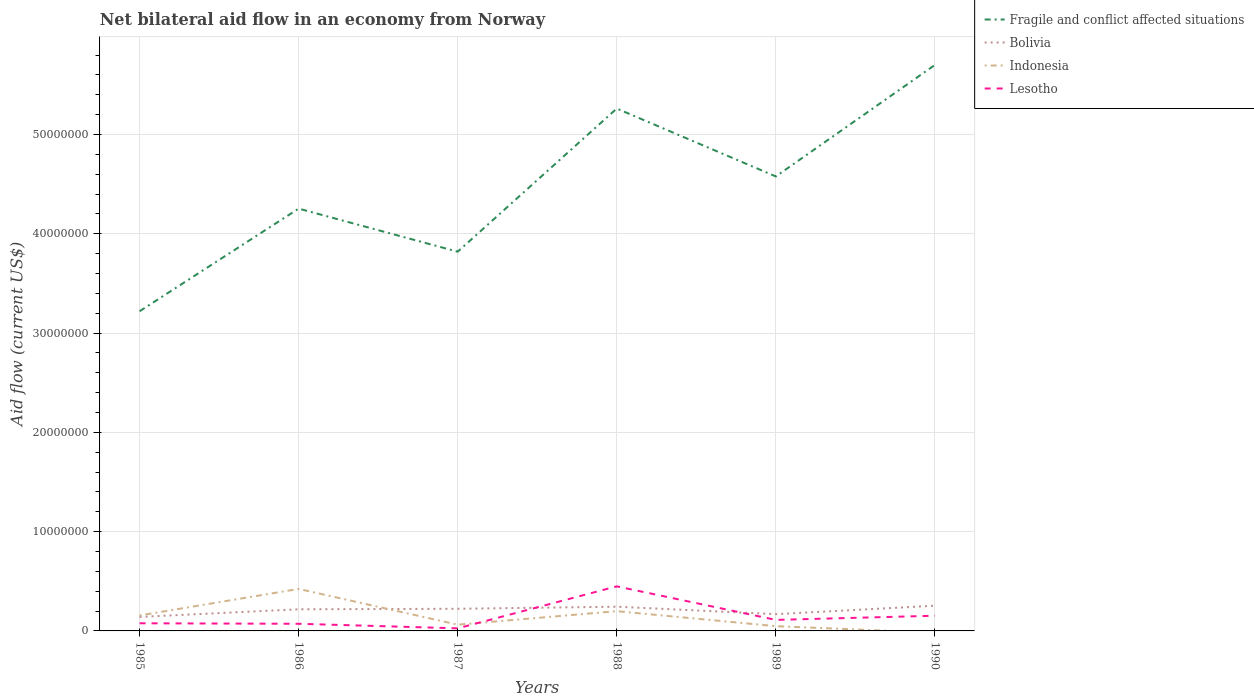Across all years, what is the maximum net bilateral aid flow in Bolivia?
Your answer should be compact. 1.41e+06. What is the total net bilateral aid flow in Lesotho in the graph?
Keep it short and to the point. 5.00e+04. What is the difference between the highest and the second highest net bilateral aid flow in Fragile and conflict affected situations?
Offer a very short reply. 2.48e+07. Is the net bilateral aid flow in Bolivia strictly greater than the net bilateral aid flow in Lesotho over the years?
Provide a succinct answer. No. How many years are there in the graph?
Your answer should be very brief. 6. Are the values on the major ticks of Y-axis written in scientific E-notation?
Provide a short and direct response. No. Where does the legend appear in the graph?
Make the answer very short. Top right. How many legend labels are there?
Offer a terse response. 4. What is the title of the graph?
Your answer should be compact. Net bilateral aid flow in an economy from Norway. What is the label or title of the Y-axis?
Your response must be concise. Aid flow (current US$). What is the Aid flow (current US$) in Fragile and conflict affected situations in 1985?
Provide a succinct answer. 3.22e+07. What is the Aid flow (current US$) of Bolivia in 1985?
Keep it short and to the point. 1.41e+06. What is the Aid flow (current US$) in Indonesia in 1985?
Offer a very short reply. 1.56e+06. What is the Aid flow (current US$) of Lesotho in 1985?
Ensure brevity in your answer.  7.70e+05. What is the Aid flow (current US$) in Fragile and conflict affected situations in 1986?
Your answer should be compact. 4.25e+07. What is the Aid flow (current US$) of Bolivia in 1986?
Provide a succinct answer. 2.18e+06. What is the Aid flow (current US$) in Indonesia in 1986?
Make the answer very short. 4.23e+06. What is the Aid flow (current US$) in Lesotho in 1986?
Provide a short and direct response. 7.20e+05. What is the Aid flow (current US$) of Fragile and conflict affected situations in 1987?
Offer a very short reply. 3.82e+07. What is the Aid flow (current US$) of Bolivia in 1987?
Offer a terse response. 2.23e+06. What is the Aid flow (current US$) of Indonesia in 1987?
Offer a terse response. 6.30e+05. What is the Aid flow (current US$) in Fragile and conflict affected situations in 1988?
Offer a very short reply. 5.26e+07. What is the Aid flow (current US$) in Bolivia in 1988?
Ensure brevity in your answer.  2.44e+06. What is the Aid flow (current US$) in Indonesia in 1988?
Make the answer very short. 1.99e+06. What is the Aid flow (current US$) in Lesotho in 1988?
Your answer should be very brief. 4.49e+06. What is the Aid flow (current US$) in Fragile and conflict affected situations in 1989?
Give a very brief answer. 4.58e+07. What is the Aid flow (current US$) of Bolivia in 1989?
Offer a terse response. 1.69e+06. What is the Aid flow (current US$) of Lesotho in 1989?
Offer a very short reply. 1.11e+06. What is the Aid flow (current US$) in Fragile and conflict affected situations in 1990?
Keep it short and to the point. 5.70e+07. What is the Aid flow (current US$) in Bolivia in 1990?
Your answer should be compact. 2.54e+06. What is the Aid flow (current US$) in Indonesia in 1990?
Offer a very short reply. 0. What is the Aid flow (current US$) of Lesotho in 1990?
Keep it short and to the point. 1.53e+06. Across all years, what is the maximum Aid flow (current US$) in Fragile and conflict affected situations?
Your response must be concise. 5.70e+07. Across all years, what is the maximum Aid flow (current US$) in Bolivia?
Provide a short and direct response. 2.54e+06. Across all years, what is the maximum Aid flow (current US$) in Indonesia?
Ensure brevity in your answer.  4.23e+06. Across all years, what is the maximum Aid flow (current US$) of Lesotho?
Ensure brevity in your answer.  4.49e+06. Across all years, what is the minimum Aid flow (current US$) in Fragile and conflict affected situations?
Offer a terse response. 3.22e+07. Across all years, what is the minimum Aid flow (current US$) of Bolivia?
Your answer should be very brief. 1.41e+06. Across all years, what is the minimum Aid flow (current US$) in Lesotho?
Give a very brief answer. 2.60e+05. What is the total Aid flow (current US$) in Fragile and conflict affected situations in the graph?
Make the answer very short. 2.68e+08. What is the total Aid flow (current US$) of Bolivia in the graph?
Ensure brevity in your answer.  1.25e+07. What is the total Aid flow (current US$) of Indonesia in the graph?
Offer a terse response. 8.89e+06. What is the total Aid flow (current US$) in Lesotho in the graph?
Your response must be concise. 8.88e+06. What is the difference between the Aid flow (current US$) in Fragile and conflict affected situations in 1985 and that in 1986?
Your answer should be very brief. -1.03e+07. What is the difference between the Aid flow (current US$) of Bolivia in 1985 and that in 1986?
Keep it short and to the point. -7.70e+05. What is the difference between the Aid flow (current US$) in Indonesia in 1985 and that in 1986?
Offer a very short reply. -2.67e+06. What is the difference between the Aid flow (current US$) in Fragile and conflict affected situations in 1985 and that in 1987?
Your answer should be very brief. -6.00e+06. What is the difference between the Aid flow (current US$) of Bolivia in 1985 and that in 1987?
Provide a succinct answer. -8.20e+05. What is the difference between the Aid flow (current US$) of Indonesia in 1985 and that in 1987?
Ensure brevity in your answer.  9.30e+05. What is the difference between the Aid flow (current US$) of Lesotho in 1985 and that in 1987?
Your answer should be compact. 5.10e+05. What is the difference between the Aid flow (current US$) in Fragile and conflict affected situations in 1985 and that in 1988?
Offer a terse response. -2.04e+07. What is the difference between the Aid flow (current US$) of Bolivia in 1985 and that in 1988?
Offer a terse response. -1.03e+06. What is the difference between the Aid flow (current US$) of Indonesia in 1985 and that in 1988?
Keep it short and to the point. -4.30e+05. What is the difference between the Aid flow (current US$) of Lesotho in 1985 and that in 1988?
Your answer should be very brief. -3.72e+06. What is the difference between the Aid flow (current US$) in Fragile and conflict affected situations in 1985 and that in 1989?
Provide a succinct answer. -1.36e+07. What is the difference between the Aid flow (current US$) of Bolivia in 1985 and that in 1989?
Give a very brief answer. -2.80e+05. What is the difference between the Aid flow (current US$) of Indonesia in 1985 and that in 1989?
Your response must be concise. 1.08e+06. What is the difference between the Aid flow (current US$) in Fragile and conflict affected situations in 1985 and that in 1990?
Provide a succinct answer. -2.48e+07. What is the difference between the Aid flow (current US$) of Bolivia in 1985 and that in 1990?
Keep it short and to the point. -1.13e+06. What is the difference between the Aid flow (current US$) in Lesotho in 1985 and that in 1990?
Your answer should be compact. -7.60e+05. What is the difference between the Aid flow (current US$) in Fragile and conflict affected situations in 1986 and that in 1987?
Your response must be concise. 4.34e+06. What is the difference between the Aid flow (current US$) of Bolivia in 1986 and that in 1987?
Your response must be concise. -5.00e+04. What is the difference between the Aid flow (current US$) of Indonesia in 1986 and that in 1987?
Offer a terse response. 3.60e+06. What is the difference between the Aid flow (current US$) in Lesotho in 1986 and that in 1987?
Your response must be concise. 4.60e+05. What is the difference between the Aid flow (current US$) of Fragile and conflict affected situations in 1986 and that in 1988?
Provide a succinct answer. -1.01e+07. What is the difference between the Aid flow (current US$) of Indonesia in 1986 and that in 1988?
Your answer should be compact. 2.24e+06. What is the difference between the Aid flow (current US$) in Lesotho in 1986 and that in 1988?
Your answer should be very brief. -3.77e+06. What is the difference between the Aid flow (current US$) in Fragile and conflict affected situations in 1986 and that in 1989?
Provide a succinct answer. -3.24e+06. What is the difference between the Aid flow (current US$) of Indonesia in 1986 and that in 1989?
Offer a very short reply. 3.75e+06. What is the difference between the Aid flow (current US$) in Lesotho in 1986 and that in 1989?
Provide a short and direct response. -3.90e+05. What is the difference between the Aid flow (current US$) in Fragile and conflict affected situations in 1986 and that in 1990?
Your answer should be compact. -1.45e+07. What is the difference between the Aid flow (current US$) in Bolivia in 1986 and that in 1990?
Your answer should be very brief. -3.60e+05. What is the difference between the Aid flow (current US$) of Lesotho in 1986 and that in 1990?
Offer a very short reply. -8.10e+05. What is the difference between the Aid flow (current US$) in Fragile and conflict affected situations in 1987 and that in 1988?
Make the answer very short. -1.44e+07. What is the difference between the Aid flow (current US$) of Indonesia in 1987 and that in 1988?
Offer a terse response. -1.36e+06. What is the difference between the Aid flow (current US$) of Lesotho in 1987 and that in 1988?
Give a very brief answer. -4.23e+06. What is the difference between the Aid flow (current US$) of Fragile and conflict affected situations in 1987 and that in 1989?
Your answer should be very brief. -7.58e+06. What is the difference between the Aid flow (current US$) of Bolivia in 1987 and that in 1989?
Ensure brevity in your answer.  5.40e+05. What is the difference between the Aid flow (current US$) in Indonesia in 1987 and that in 1989?
Your answer should be compact. 1.50e+05. What is the difference between the Aid flow (current US$) in Lesotho in 1987 and that in 1989?
Make the answer very short. -8.50e+05. What is the difference between the Aid flow (current US$) in Fragile and conflict affected situations in 1987 and that in 1990?
Offer a terse response. -1.88e+07. What is the difference between the Aid flow (current US$) in Bolivia in 1987 and that in 1990?
Provide a succinct answer. -3.10e+05. What is the difference between the Aid flow (current US$) in Lesotho in 1987 and that in 1990?
Your answer should be very brief. -1.27e+06. What is the difference between the Aid flow (current US$) of Fragile and conflict affected situations in 1988 and that in 1989?
Give a very brief answer. 6.84e+06. What is the difference between the Aid flow (current US$) in Bolivia in 1988 and that in 1989?
Give a very brief answer. 7.50e+05. What is the difference between the Aid flow (current US$) in Indonesia in 1988 and that in 1989?
Your response must be concise. 1.51e+06. What is the difference between the Aid flow (current US$) of Lesotho in 1988 and that in 1989?
Ensure brevity in your answer.  3.38e+06. What is the difference between the Aid flow (current US$) in Fragile and conflict affected situations in 1988 and that in 1990?
Offer a terse response. -4.39e+06. What is the difference between the Aid flow (current US$) in Bolivia in 1988 and that in 1990?
Keep it short and to the point. -1.00e+05. What is the difference between the Aid flow (current US$) in Lesotho in 1988 and that in 1990?
Your answer should be compact. 2.96e+06. What is the difference between the Aid flow (current US$) of Fragile and conflict affected situations in 1989 and that in 1990?
Provide a succinct answer. -1.12e+07. What is the difference between the Aid flow (current US$) of Bolivia in 1989 and that in 1990?
Make the answer very short. -8.50e+05. What is the difference between the Aid flow (current US$) of Lesotho in 1989 and that in 1990?
Provide a succinct answer. -4.20e+05. What is the difference between the Aid flow (current US$) in Fragile and conflict affected situations in 1985 and the Aid flow (current US$) in Bolivia in 1986?
Provide a short and direct response. 3.00e+07. What is the difference between the Aid flow (current US$) in Fragile and conflict affected situations in 1985 and the Aid flow (current US$) in Indonesia in 1986?
Provide a short and direct response. 2.80e+07. What is the difference between the Aid flow (current US$) in Fragile and conflict affected situations in 1985 and the Aid flow (current US$) in Lesotho in 1986?
Give a very brief answer. 3.15e+07. What is the difference between the Aid flow (current US$) of Bolivia in 1985 and the Aid flow (current US$) of Indonesia in 1986?
Keep it short and to the point. -2.82e+06. What is the difference between the Aid flow (current US$) in Bolivia in 1985 and the Aid flow (current US$) in Lesotho in 1986?
Your answer should be compact. 6.90e+05. What is the difference between the Aid flow (current US$) of Indonesia in 1985 and the Aid flow (current US$) of Lesotho in 1986?
Offer a very short reply. 8.40e+05. What is the difference between the Aid flow (current US$) in Fragile and conflict affected situations in 1985 and the Aid flow (current US$) in Bolivia in 1987?
Your answer should be compact. 3.00e+07. What is the difference between the Aid flow (current US$) of Fragile and conflict affected situations in 1985 and the Aid flow (current US$) of Indonesia in 1987?
Keep it short and to the point. 3.16e+07. What is the difference between the Aid flow (current US$) of Fragile and conflict affected situations in 1985 and the Aid flow (current US$) of Lesotho in 1987?
Your response must be concise. 3.19e+07. What is the difference between the Aid flow (current US$) of Bolivia in 1985 and the Aid flow (current US$) of Indonesia in 1987?
Ensure brevity in your answer.  7.80e+05. What is the difference between the Aid flow (current US$) of Bolivia in 1985 and the Aid flow (current US$) of Lesotho in 1987?
Make the answer very short. 1.15e+06. What is the difference between the Aid flow (current US$) of Indonesia in 1985 and the Aid flow (current US$) of Lesotho in 1987?
Your answer should be compact. 1.30e+06. What is the difference between the Aid flow (current US$) of Fragile and conflict affected situations in 1985 and the Aid flow (current US$) of Bolivia in 1988?
Ensure brevity in your answer.  2.98e+07. What is the difference between the Aid flow (current US$) in Fragile and conflict affected situations in 1985 and the Aid flow (current US$) in Indonesia in 1988?
Offer a very short reply. 3.02e+07. What is the difference between the Aid flow (current US$) of Fragile and conflict affected situations in 1985 and the Aid flow (current US$) of Lesotho in 1988?
Provide a short and direct response. 2.77e+07. What is the difference between the Aid flow (current US$) in Bolivia in 1985 and the Aid flow (current US$) in Indonesia in 1988?
Give a very brief answer. -5.80e+05. What is the difference between the Aid flow (current US$) in Bolivia in 1985 and the Aid flow (current US$) in Lesotho in 1988?
Ensure brevity in your answer.  -3.08e+06. What is the difference between the Aid flow (current US$) of Indonesia in 1985 and the Aid flow (current US$) of Lesotho in 1988?
Provide a succinct answer. -2.93e+06. What is the difference between the Aid flow (current US$) in Fragile and conflict affected situations in 1985 and the Aid flow (current US$) in Bolivia in 1989?
Offer a very short reply. 3.05e+07. What is the difference between the Aid flow (current US$) in Fragile and conflict affected situations in 1985 and the Aid flow (current US$) in Indonesia in 1989?
Keep it short and to the point. 3.17e+07. What is the difference between the Aid flow (current US$) in Fragile and conflict affected situations in 1985 and the Aid flow (current US$) in Lesotho in 1989?
Provide a succinct answer. 3.11e+07. What is the difference between the Aid flow (current US$) of Bolivia in 1985 and the Aid flow (current US$) of Indonesia in 1989?
Your answer should be compact. 9.30e+05. What is the difference between the Aid flow (current US$) of Indonesia in 1985 and the Aid flow (current US$) of Lesotho in 1989?
Make the answer very short. 4.50e+05. What is the difference between the Aid flow (current US$) of Fragile and conflict affected situations in 1985 and the Aid flow (current US$) of Bolivia in 1990?
Your answer should be very brief. 2.97e+07. What is the difference between the Aid flow (current US$) of Fragile and conflict affected situations in 1985 and the Aid flow (current US$) of Lesotho in 1990?
Your answer should be very brief. 3.07e+07. What is the difference between the Aid flow (current US$) of Fragile and conflict affected situations in 1986 and the Aid flow (current US$) of Bolivia in 1987?
Your answer should be compact. 4.03e+07. What is the difference between the Aid flow (current US$) of Fragile and conflict affected situations in 1986 and the Aid flow (current US$) of Indonesia in 1987?
Offer a very short reply. 4.19e+07. What is the difference between the Aid flow (current US$) of Fragile and conflict affected situations in 1986 and the Aid flow (current US$) of Lesotho in 1987?
Make the answer very short. 4.23e+07. What is the difference between the Aid flow (current US$) in Bolivia in 1986 and the Aid flow (current US$) in Indonesia in 1987?
Your response must be concise. 1.55e+06. What is the difference between the Aid flow (current US$) of Bolivia in 1986 and the Aid flow (current US$) of Lesotho in 1987?
Your answer should be compact. 1.92e+06. What is the difference between the Aid flow (current US$) in Indonesia in 1986 and the Aid flow (current US$) in Lesotho in 1987?
Make the answer very short. 3.97e+06. What is the difference between the Aid flow (current US$) in Fragile and conflict affected situations in 1986 and the Aid flow (current US$) in Bolivia in 1988?
Make the answer very short. 4.01e+07. What is the difference between the Aid flow (current US$) in Fragile and conflict affected situations in 1986 and the Aid flow (current US$) in Indonesia in 1988?
Keep it short and to the point. 4.06e+07. What is the difference between the Aid flow (current US$) of Fragile and conflict affected situations in 1986 and the Aid flow (current US$) of Lesotho in 1988?
Ensure brevity in your answer.  3.80e+07. What is the difference between the Aid flow (current US$) of Bolivia in 1986 and the Aid flow (current US$) of Indonesia in 1988?
Give a very brief answer. 1.90e+05. What is the difference between the Aid flow (current US$) of Bolivia in 1986 and the Aid flow (current US$) of Lesotho in 1988?
Provide a succinct answer. -2.31e+06. What is the difference between the Aid flow (current US$) of Indonesia in 1986 and the Aid flow (current US$) of Lesotho in 1988?
Offer a terse response. -2.60e+05. What is the difference between the Aid flow (current US$) of Fragile and conflict affected situations in 1986 and the Aid flow (current US$) of Bolivia in 1989?
Give a very brief answer. 4.08e+07. What is the difference between the Aid flow (current US$) in Fragile and conflict affected situations in 1986 and the Aid flow (current US$) in Indonesia in 1989?
Offer a terse response. 4.21e+07. What is the difference between the Aid flow (current US$) of Fragile and conflict affected situations in 1986 and the Aid flow (current US$) of Lesotho in 1989?
Make the answer very short. 4.14e+07. What is the difference between the Aid flow (current US$) in Bolivia in 1986 and the Aid flow (current US$) in Indonesia in 1989?
Offer a terse response. 1.70e+06. What is the difference between the Aid flow (current US$) of Bolivia in 1986 and the Aid flow (current US$) of Lesotho in 1989?
Offer a terse response. 1.07e+06. What is the difference between the Aid flow (current US$) of Indonesia in 1986 and the Aid flow (current US$) of Lesotho in 1989?
Offer a very short reply. 3.12e+06. What is the difference between the Aid flow (current US$) of Fragile and conflict affected situations in 1986 and the Aid flow (current US$) of Bolivia in 1990?
Your answer should be very brief. 4.00e+07. What is the difference between the Aid flow (current US$) in Fragile and conflict affected situations in 1986 and the Aid flow (current US$) in Lesotho in 1990?
Provide a short and direct response. 4.10e+07. What is the difference between the Aid flow (current US$) of Bolivia in 1986 and the Aid flow (current US$) of Lesotho in 1990?
Your response must be concise. 6.50e+05. What is the difference between the Aid flow (current US$) of Indonesia in 1986 and the Aid flow (current US$) of Lesotho in 1990?
Provide a succinct answer. 2.70e+06. What is the difference between the Aid flow (current US$) of Fragile and conflict affected situations in 1987 and the Aid flow (current US$) of Bolivia in 1988?
Ensure brevity in your answer.  3.58e+07. What is the difference between the Aid flow (current US$) of Fragile and conflict affected situations in 1987 and the Aid flow (current US$) of Indonesia in 1988?
Your answer should be compact. 3.62e+07. What is the difference between the Aid flow (current US$) of Fragile and conflict affected situations in 1987 and the Aid flow (current US$) of Lesotho in 1988?
Give a very brief answer. 3.37e+07. What is the difference between the Aid flow (current US$) of Bolivia in 1987 and the Aid flow (current US$) of Indonesia in 1988?
Give a very brief answer. 2.40e+05. What is the difference between the Aid flow (current US$) in Bolivia in 1987 and the Aid flow (current US$) in Lesotho in 1988?
Ensure brevity in your answer.  -2.26e+06. What is the difference between the Aid flow (current US$) of Indonesia in 1987 and the Aid flow (current US$) of Lesotho in 1988?
Give a very brief answer. -3.86e+06. What is the difference between the Aid flow (current US$) of Fragile and conflict affected situations in 1987 and the Aid flow (current US$) of Bolivia in 1989?
Your answer should be very brief. 3.65e+07. What is the difference between the Aid flow (current US$) in Fragile and conflict affected situations in 1987 and the Aid flow (current US$) in Indonesia in 1989?
Give a very brief answer. 3.77e+07. What is the difference between the Aid flow (current US$) in Fragile and conflict affected situations in 1987 and the Aid flow (current US$) in Lesotho in 1989?
Your answer should be very brief. 3.71e+07. What is the difference between the Aid flow (current US$) of Bolivia in 1987 and the Aid flow (current US$) of Indonesia in 1989?
Make the answer very short. 1.75e+06. What is the difference between the Aid flow (current US$) in Bolivia in 1987 and the Aid flow (current US$) in Lesotho in 1989?
Offer a very short reply. 1.12e+06. What is the difference between the Aid flow (current US$) in Indonesia in 1987 and the Aid flow (current US$) in Lesotho in 1989?
Provide a short and direct response. -4.80e+05. What is the difference between the Aid flow (current US$) in Fragile and conflict affected situations in 1987 and the Aid flow (current US$) in Bolivia in 1990?
Provide a succinct answer. 3.57e+07. What is the difference between the Aid flow (current US$) of Fragile and conflict affected situations in 1987 and the Aid flow (current US$) of Lesotho in 1990?
Offer a very short reply. 3.67e+07. What is the difference between the Aid flow (current US$) in Bolivia in 1987 and the Aid flow (current US$) in Lesotho in 1990?
Your response must be concise. 7.00e+05. What is the difference between the Aid flow (current US$) of Indonesia in 1987 and the Aid flow (current US$) of Lesotho in 1990?
Ensure brevity in your answer.  -9.00e+05. What is the difference between the Aid flow (current US$) in Fragile and conflict affected situations in 1988 and the Aid flow (current US$) in Bolivia in 1989?
Ensure brevity in your answer.  5.09e+07. What is the difference between the Aid flow (current US$) in Fragile and conflict affected situations in 1988 and the Aid flow (current US$) in Indonesia in 1989?
Ensure brevity in your answer.  5.21e+07. What is the difference between the Aid flow (current US$) in Fragile and conflict affected situations in 1988 and the Aid flow (current US$) in Lesotho in 1989?
Give a very brief answer. 5.15e+07. What is the difference between the Aid flow (current US$) of Bolivia in 1988 and the Aid flow (current US$) of Indonesia in 1989?
Provide a short and direct response. 1.96e+06. What is the difference between the Aid flow (current US$) of Bolivia in 1988 and the Aid flow (current US$) of Lesotho in 1989?
Your answer should be compact. 1.33e+06. What is the difference between the Aid flow (current US$) of Indonesia in 1988 and the Aid flow (current US$) of Lesotho in 1989?
Keep it short and to the point. 8.80e+05. What is the difference between the Aid flow (current US$) of Fragile and conflict affected situations in 1988 and the Aid flow (current US$) of Bolivia in 1990?
Offer a very short reply. 5.01e+07. What is the difference between the Aid flow (current US$) of Fragile and conflict affected situations in 1988 and the Aid flow (current US$) of Lesotho in 1990?
Your answer should be very brief. 5.11e+07. What is the difference between the Aid flow (current US$) of Bolivia in 1988 and the Aid flow (current US$) of Lesotho in 1990?
Provide a succinct answer. 9.10e+05. What is the difference between the Aid flow (current US$) in Fragile and conflict affected situations in 1989 and the Aid flow (current US$) in Bolivia in 1990?
Provide a short and direct response. 4.32e+07. What is the difference between the Aid flow (current US$) in Fragile and conflict affected situations in 1989 and the Aid flow (current US$) in Lesotho in 1990?
Ensure brevity in your answer.  4.42e+07. What is the difference between the Aid flow (current US$) in Bolivia in 1989 and the Aid flow (current US$) in Lesotho in 1990?
Give a very brief answer. 1.60e+05. What is the difference between the Aid flow (current US$) of Indonesia in 1989 and the Aid flow (current US$) of Lesotho in 1990?
Give a very brief answer. -1.05e+06. What is the average Aid flow (current US$) in Fragile and conflict affected situations per year?
Your response must be concise. 4.47e+07. What is the average Aid flow (current US$) of Bolivia per year?
Provide a short and direct response. 2.08e+06. What is the average Aid flow (current US$) of Indonesia per year?
Your answer should be compact. 1.48e+06. What is the average Aid flow (current US$) in Lesotho per year?
Give a very brief answer. 1.48e+06. In the year 1985, what is the difference between the Aid flow (current US$) of Fragile and conflict affected situations and Aid flow (current US$) of Bolivia?
Ensure brevity in your answer.  3.08e+07. In the year 1985, what is the difference between the Aid flow (current US$) in Fragile and conflict affected situations and Aid flow (current US$) in Indonesia?
Your answer should be very brief. 3.06e+07. In the year 1985, what is the difference between the Aid flow (current US$) of Fragile and conflict affected situations and Aid flow (current US$) of Lesotho?
Give a very brief answer. 3.14e+07. In the year 1985, what is the difference between the Aid flow (current US$) in Bolivia and Aid flow (current US$) in Indonesia?
Keep it short and to the point. -1.50e+05. In the year 1985, what is the difference between the Aid flow (current US$) in Bolivia and Aid flow (current US$) in Lesotho?
Provide a succinct answer. 6.40e+05. In the year 1985, what is the difference between the Aid flow (current US$) in Indonesia and Aid flow (current US$) in Lesotho?
Make the answer very short. 7.90e+05. In the year 1986, what is the difference between the Aid flow (current US$) in Fragile and conflict affected situations and Aid flow (current US$) in Bolivia?
Make the answer very short. 4.04e+07. In the year 1986, what is the difference between the Aid flow (current US$) in Fragile and conflict affected situations and Aid flow (current US$) in Indonesia?
Ensure brevity in your answer.  3.83e+07. In the year 1986, what is the difference between the Aid flow (current US$) in Fragile and conflict affected situations and Aid flow (current US$) in Lesotho?
Your answer should be very brief. 4.18e+07. In the year 1986, what is the difference between the Aid flow (current US$) in Bolivia and Aid flow (current US$) in Indonesia?
Give a very brief answer. -2.05e+06. In the year 1986, what is the difference between the Aid flow (current US$) of Bolivia and Aid flow (current US$) of Lesotho?
Keep it short and to the point. 1.46e+06. In the year 1986, what is the difference between the Aid flow (current US$) of Indonesia and Aid flow (current US$) of Lesotho?
Keep it short and to the point. 3.51e+06. In the year 1987, what is the difference between the Aid flow (current US$) in Fragile and conflict affected situations and Aid flow (current US$) in Bolivia?
Your answer should be very brief. 3.60e+07. In the year 1987, what is the difference between the Aid flow (current US$) of Fragile and conflict affected situations and Aid flow (current US$) of Indonesia?
Ensure brevity in your answer.  3.76e+07. In the year 1987, what is the difference between the Aid flow (current US$) in Fragile and conflict affected situations and Aid flow (current US$) in Lesotho?
Your answer should be very brief. 3.79e+07. In the year 1987, what is the difference between the Aid flow (current US$) in Bolivia and Aid flow (current US$) in Indonesia?
Give a very brief answer. 1.60e+06. In the year 1987, what is the difference between the Aid flow (current US$) of Bolivia and Aid flow (current US$) of Lesotho?
Provide a succinct answer. 1.97e+06. In the year 1987, what is the difference between the Aid flow (current US$) in Indonesia and Aid flow (current US$) in Lesotho?
Provide a short and direct response. 3.70e+05. In the year 1988, what is the difference between the Aid flow (current US$) of Fragile and conflict affected situations and Aid flow (current US$) of Bolivia?
Provide a short and direct response. 5.02e+07. In the year 1988, what is the difference between the Aid flow (current US$) of Fragile and conflict affected situations and Aid flow (current US$) of Indonesia?
Your answer should be very brief. 5.06e+07. In the year 1988, what is the difference between the Aid flow (current US$) of Fragile and conflict affected situations and Aid flow (current US$) of Lesotho?
Provide a short and direct response. 4.81e+07. In the year 1988, what is the difference between the Aid flow (current US$) of Bolivia and Aid flow (current US$) of Lesotho?
Your answer should be compact. -2.05e+06. In the year 1988, what is the difference between the Aid flow (current US$) in Indonesia and Aid flow (current US$) in Lesotho?
Provide a succinct answer. -2.50e+06. In the year 1989, what is the difference between the Aid flow (current US$) in Fragile and conflict affected situations and Aid flow (current US$) in Bolivia?
Offer a very short reply. 4.41e+07. In the year 1989, what is the difference between the Aid flow (current US$) in Fragile and conflict affected situations and Aid flow (current US$) in Indonesia?
Offer a very short reply. 4.53e+07. In the year 1989, what is the difference between the Aid flow (current US$) of Fragile and conflict affected situations and Aid flow (current US$) of Lesotho?
Offer a very short reply. 4.47e+07. In the year 1989, what is the difference between the Aid flow (current US$) of Bolivia and Aid flow (current US$) of Indonesia?
Your response must be concise. 1.21e+06. In the year 1989, what is the difference between the Aid flow (current US$) in Bolivia and Aid flow (current US$) in Lesotho?
Give a very brief answer. 5.80e+05. In the year 1989, what is the difference between the Aid flow (current US$) in Indonesia and Aid flow (current US$) in Lesotho?
Ensure brevity in your answer.  -6.30e+05. In the year 1990, what is the difference between the Aid flow (current US$) in Fragile and conflict affected situations and Aid flow (current US$) in Bolivia?
Keep it short and to the point. 5.45e+07. In the year 1990, what is the difference between the Aid flow (current US$) in Fragile and conflict affected situations and Aid flow (current US$) in Lesotho?
Your response must be concise. 5.55e+07. In the year 1990, what is the difference between the Aid flow (current US$) in Bolivia and Aid flow (current US$) in Lesotho?
Give a very brief answer. 1.01e+06. What is the ratio of the Aid flow (current US$) in Fragile and conflict affected situations in 1985 to that in 1986?
Your answer should be very brief. 0.76. What is the ratio of the Aid flow (current US$) of Bolivia in 1985 to that in 1986?
Ensure brevity in your answer.  0.65. What is the ratio of the Aid flow (current US$) of Indonesia in 1985 to that in 1986?
Your answer should be very brief. 0.37. What is the ratio of the Aid flow (current US$) of Lesotho in 1985 to that in 1986?
Keep it short and to the point. 1.07. What is the ratio of the Aid flow (current US$) of Fragile and conflict affected situations in 1985 to that in 1987?
Offer a very short reply. 0.84. What is the ratio of the Aid flow (current US$) in Bolivia in 1985 to that in 1987?
Make the answer very short. 0.63. What is the ratio of the Aid flow (current US$) in Indonesia in 1985 to that in 1987?
Make the answer very short. 2.48. What is the ratio of the Aid flow (current US$) in Lesotho in 1985 to that in 1987?
Give a very brief answer. 2.96. What is the ratio of the Aid flow (current US$) of Fragile and conflict affected situations in 1985 to that in 1988?
Provide a short and direct response. 0.61. What is the ratio of the Aid flow (current US$) of Bolivia in 1985 to that in 1988?
Your answer should be compact. 0.58. What is the ratio of the Aid flow (current US$) of Indonesia in 1985 to that in 1988?
Ensure brevity in your answer.  0.78. What is the ratio of the Aid flow (current US$) of Lesotho in 1985 to that in 1988?
Provide a short and direct response. 0.17. What is the ratio of the Aid flow (current US$) of Fragile and conflict affected situations in 1985 to that in 1989?
Provide a succinct answer. 0.7. What is the ratio of the Aid flow (current US$) of Bolivia in 1985 to that in 1989?
Provide a succinct answer. 0.83. What is the ratio of the Aid flow (current US$) in Indonesia in 1985 to that in 1989?
Provide a succinct answer. 3.25. What is the ratio of the Aid flow (current US$) in Lesotho in 1985 to that in 1989?
Offer a very short reply. 0.69. What is the ratio of the Aid flow (current US$) in Fragile and conflict affected situations in 1985 to that in 1990?
Your response must be concise. 0.56. What is the ratio of the Aid flow (current US$) in Bolivia in 1985 to that in 1990?
Give a very brief answer. 0.56. What is the ratio of the Aid flow (current US$) in Lesotho in 1985 to that in 1990?
Provide a succinct answer. 0.5. What is the ratio of the Aid flow (current US$) in Fragile and conflict affected situations in 1986 to that in 1987?
Your answer should be very brief. 1.11. What is the ratio of the Aid flow (current US$) of Bolivia in 1986 to that in 1987?
Your answer should be compact. 0.98. What is the ratio of the Aid flow (current US$) of Indonesia in 1986 to that in 1987?
Make the answer very short. 6.71. What is the ratio of the Aid flow (current US$) of Lesotho in 1986 to that in 1987?
Keep it short and to the point. 2.77. What is the ratio of the Aid flow (current US$) in Fragile and conflict affected situations in 1986 to that in 1988?
Keep it short and to the point. 0.81. What is the ratio of the Aid flow (current US$) in Bolivia in 1986 to that in 1988?
Your answer should be very brief. 0.89. What is the ratio of the Aid flow (current US$) in Indonesia in 1986 to that in 1988?
Your answer should be compact. 2.13. What is the ratio of the Aid flow (current US$) in Lesotho in 1986 to that in 1988?
Your response must be concise. 0.16. What is the ratio of the Aid flow (current US$) of Fragile and conflict affected situations in 1986 to that in 1989?
Make the answer very short. 0.93. What is the ratio of the Aid flow (current US$) in Bolivia in 1986 to that in 1989?
Keep it short and to the point. 1.29. What is the ratio of the Aid flow (current US$) of Indonesia in 1986 to that in 1989?
Provide a short and direct response. 8.81. What is the ratio of the Aid flow (current US$) in Lesotho in 1986 to that in 1989?
Offer a very short reply. 0.65. What is the ratio of the Aid flow (current US$) of Fragile and conflict affected situations in 1986 to that in 1990?
Offer a very short reply. 0.75. What is the ratio of the Aid flow (current US$) in Bolivia in 1986 to that in 1990?
Make the answer very short. 0.86. What is the ratio of the Aid flow (current US$) of Lesotho in 1986 to that in 1990?
Your answer should be very brief. 0.47. What is the ratio of the Aid flow (current US$) of Fragile and conflict affected situations in 1987 to that in 1988?
Your answer should be very brief. 0.73. What is the ratio of the Aid flow (current US$) of Bolivia in 1987 to that in 1988?
Your answer should be compact. 0.91. What is the ratio of the Aid flow (current US$) of Indonesia in 1987 to that in 1988?
Offer a very short reply. 0.32. What is the ratio of the Aid flow (current US$) in Lesotho in 1987 to that in 1988?
Keep it short and to the point. 0.06. What is the ratio of the Aid flow (current US$) in Fragile and conflict affected situations in 1987 to that in 1989?
Offer a terse response. 0.83. What is the ratio of the Aid flow (current US$) in Bolivia in 1987 to that in 1989?
Offer a terse response. 1.32. What is the ratio of the Aid flow (current US$) of Indonesia in 1987 to that in 1989?
Offer a terse response. 1.31. What is the ratio of the Aid flow (current US$) of Lesotho in 1987 to that in 1989?
Your answer should be compact. 0.23. What is the ratio of the Aid flow (current US$) in Fragile and conflict affected situations in 1987 to that in 1990?
Your answer should be compact. 0.67. What is the ratio of the Aid flow (current US$) in Bolivia in 1987 to that in 1990?
Provide a short and direct response. 0.88. What is the ratio of the Aid flow (current US$) of Lesotho in 1987 to that in 1990?
Give a very brief answer. 0.17. What is the ratio of the Aid flow (current US$) in Fragile and conflict affected situations in 1988 to that in 1989?
Give a very brief answer. 1.15. What is the ratio of the Aid flow (current US$) in Bolivia in 1988 to that in 1989?
Offer a terse response. 1.44. What is the ratio of the Aid flow (current US$) of Indonesia in 1988 to that in 1989?
Make the answer very short. 4.15. What is the ratio of the Aid flow (current US$) of Lesotho in 1988 to that in 1989?
Offer a very short reply. 4.04. What is the ratio of the Aid flow (current US$) in Fragile and conflict affected situations in 1988 to that in 1990?
Provide a short and direct response. 0.92. What is the ratio of the Aid flow (current US$) of Bolivia in 1988 to that in 1990?
Provide a succinct answer. 0.96. What is the ratio of the Aid flow (current US$) in Lesotho in 1988 to that in 1990?
Make the answer very short. 2.93. What is the ratio of the Aid flow (current US$) of Fragile and conflict affected situations in 1989 to that in 1990?
Give a very brief answer. 0.8. What is the ratio of the Aid flow (current US$) in Bolivia in 1989 to that in 1990?
Offer a very short reply. 0.67. What is the ratio of the Aid flow (current US$) in Lesotho in 1989 to that in 1990?
Give a very brief answer. 0.73. What is the difference between the highest and the second highest Aid flow (current US$) in Fragile and conflict affected situations?
Provide a succinct answer. 4.39e+06. What is the difference between the highest and the second highest Aid flow (current US$) in Bolivia?
Your answer should be very brief. 1.00e+05. What is the difference between the highest and the second highest Aid flow (current US$) in Indonesia?
Provide a succinct answer. 2.24e+06. What is the difference between the highest and the second highest Aid flow (current US$) of Lesotho?
Provide a succinct answer. 2.96e+06. What is the difference between the highest and the lowest Aid flow (current US$) in Fragile and conflict affected situations?
Provide a short and direct response. 2.48e+07. What is the difference between the highest and the lowest Aid flow (current US$) of Bolivia?
Ensure brevity in your answer.  1.13e+06. What is the difference between the highest and the lowest Aid flow (current US$) of Indonesia?
Your answer should be compact. 4.23e+06. What is the difference between the highest and the lowest Aid flow (current US$) of Lesotho?
Keep it short and to the point. 4.23e+06. 